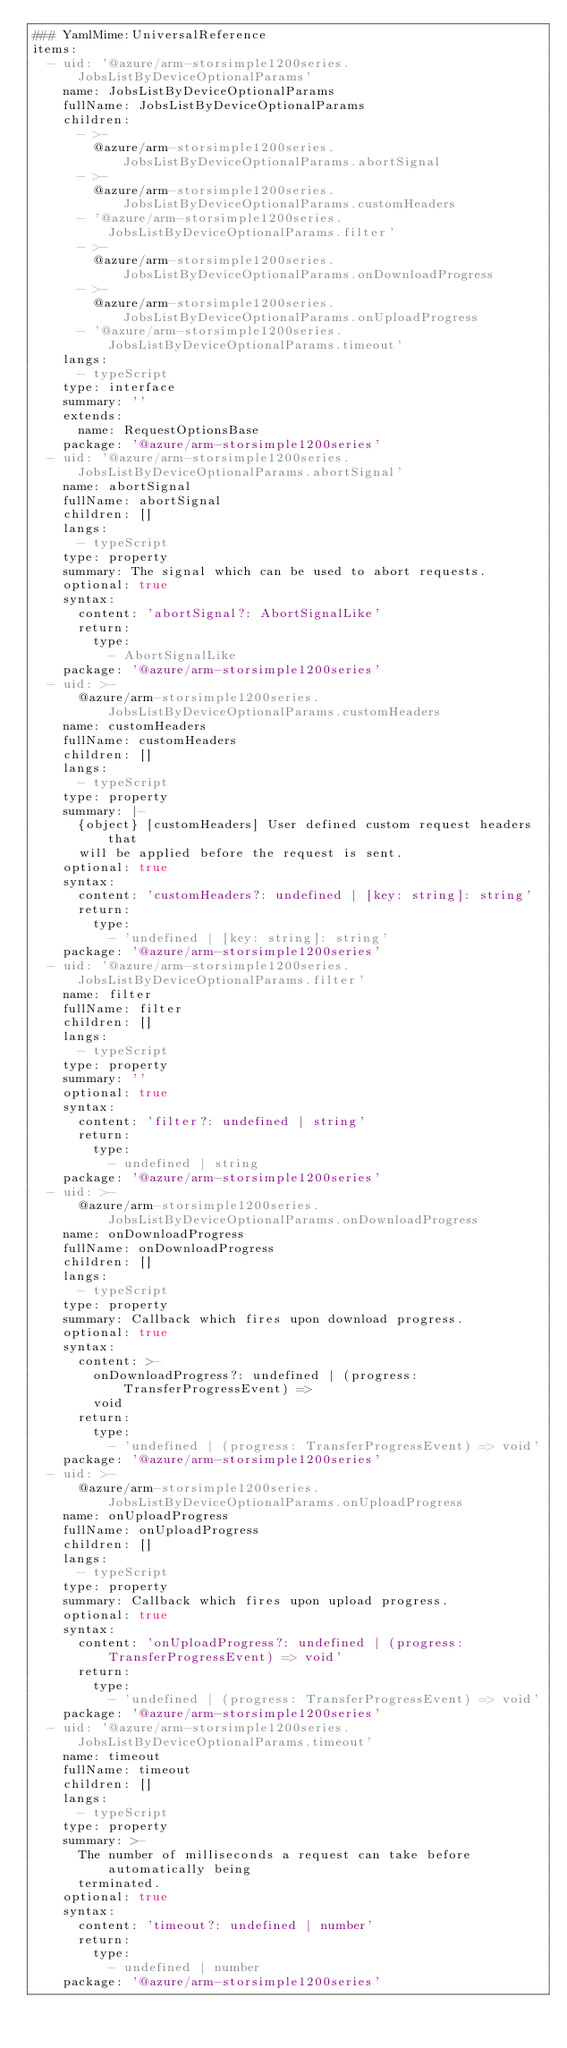<code> <loc_0><loc_0><loc_500><loc_500><_YAML_>### YamlMime:UniversalReference
items:
  - uid: '@azure/arm-storsimple1200series.JobsListByDeviceOptionalParams'
    name: JobsListByDeviceOptionalParams
    fullName: JobsListByDeviceOptionalParams
    children:
      - >-
        @azure/arm-storsimple1200series.JobsListByDeviceOptionalParams.abortSignal
      - >-
        @azure/arm-storsimple1200series.JobsListByDeviceOptionalParams.customHeaders
      - '@azure/arm-storsimple1200series.JobsListByDeviceOptionalParams.filter'
      - >-
        @azure/arm-storsimple1200series.JobsListByDeviceOptionalParams.onDownloadProgress
      - >-
        @azure/arm-storsimple1200series.JobsListByDeviceOptionalParams.onUploadProgress
      - '@azure/arm-storsimple1200series.JobsListByDeviceOptionalParams.timeout'
    langs:
      - typeScript
    type: interface
    summary: ''
    extends:
      name: RequestOptionsBase
    package: '@azure/arm-storsimple1200series'
  - uid: '@azure/arm-storsimple1200series.JobsListByDeviceOptionalParams.abortSignal'
    name: abortSignal
    fullName: abortSignal
    children: []
    langs:
      - typeScript
    type: property
    summary: The signal which can be used to abort requests.
    optional: true
    syntax:
      content: 'abortSignal?: AbortSignalLike'
      return:
        type:
          - AbortSignalLike
    package: '@azure/arm-storsimple1200series'
  - uid: >-
      @azure/arm-storsimple1200series.JobsListByDeviceOptionalParams.customHeaders
    name: customHeaders
    fullName: customHeaders
    children: []
    langs:
      - typeScript
    type: property
    summary: |-
      {object} [customHeaders] User defined custom request headers that
      will be applied before the request is sent.
    optional: true
    syntax:
      content: 'customHeaders?: undefined | [key: string]: string'
      return:
        type:
          - 'undefined | [key: string]: string'
    package: '@azure/arm-storsimple1200series'
  - uid: '@azure/arm-storsimple1200series.JobsListByDeviceOptionalParams.filter'
    name: filter
    fullName: filter
    children: []
    langs:
      - typeScript
    type: property
    summary: ''
    optional: true
    syntax:
      content: 'filter?: undefined | string'
      return:
        type:
          - undefined | string
    package: '@azure/arm-storsimple1200series'
  - uid: >-
      @azure/arm-storsimple1200series.JobsListByDeviceOptionalParams.onDownloadProgress
    name: onDownloadProgress
    fullName: onDownloadProgress
    children: []
    langs:
      - typeScript
    type: property
    summary: Callback which fires upon download progress.
    optional: true
    syntax:
      content: >-
        onDownloadProgress?: undefined | (progress: TransferProgressEvent) =>
        void
      return:
        type:
          - 'undefined | (progress: TransferProgressEvent) => void'
    package: '@azure/arm-storsimple1200series'
  - uid: >-
      @azure/arm-storsimple1200series.JobsListByDeviceOptionalParams.onUploadProgress
    name: onUploadProgress
    fullName: onUploadProgress
    children: []
    langs:
      - typeScript
    type: property
    summary: Callback which fires upon upload progress.
    optional: true
    syntax:
      content: 'onUploadProgress?: undefined | (progress: TransferProgressEvent) => void'
      return:
        type:
          - 'undefined | (progress: TransferProgressEvent) => void'
    package: '@azure/arm-storsimple1200series'
  - uid: '@azure/arm-storsimple1200series.JobsListByDeviceOptionalParams.timeout'
    name: timeout
    fullName: timeout
    children: []
    langs:
      - typeScript
    type: property
    summary: >-
      The number of milliseconds a request can take before automatically being
      terminated.
    optional: true
    syntax:
      content: 'timeout?: undefined | number'
      return:
        type:
          - undefined | number
    package: '@azure/arm-storsimple1200series'
</code> 